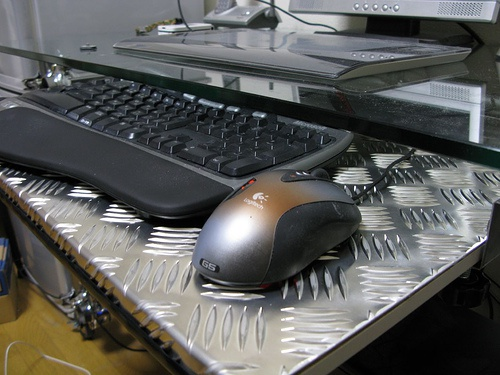Describe the objects in this image and their specific colors. I can see keyboard in gray and black tones, mouse in gray, black, and lightgray tones, tv in gray, darkgray, and black tones, and cell phone in gray, lightgray, and darkgray tones in this image. 